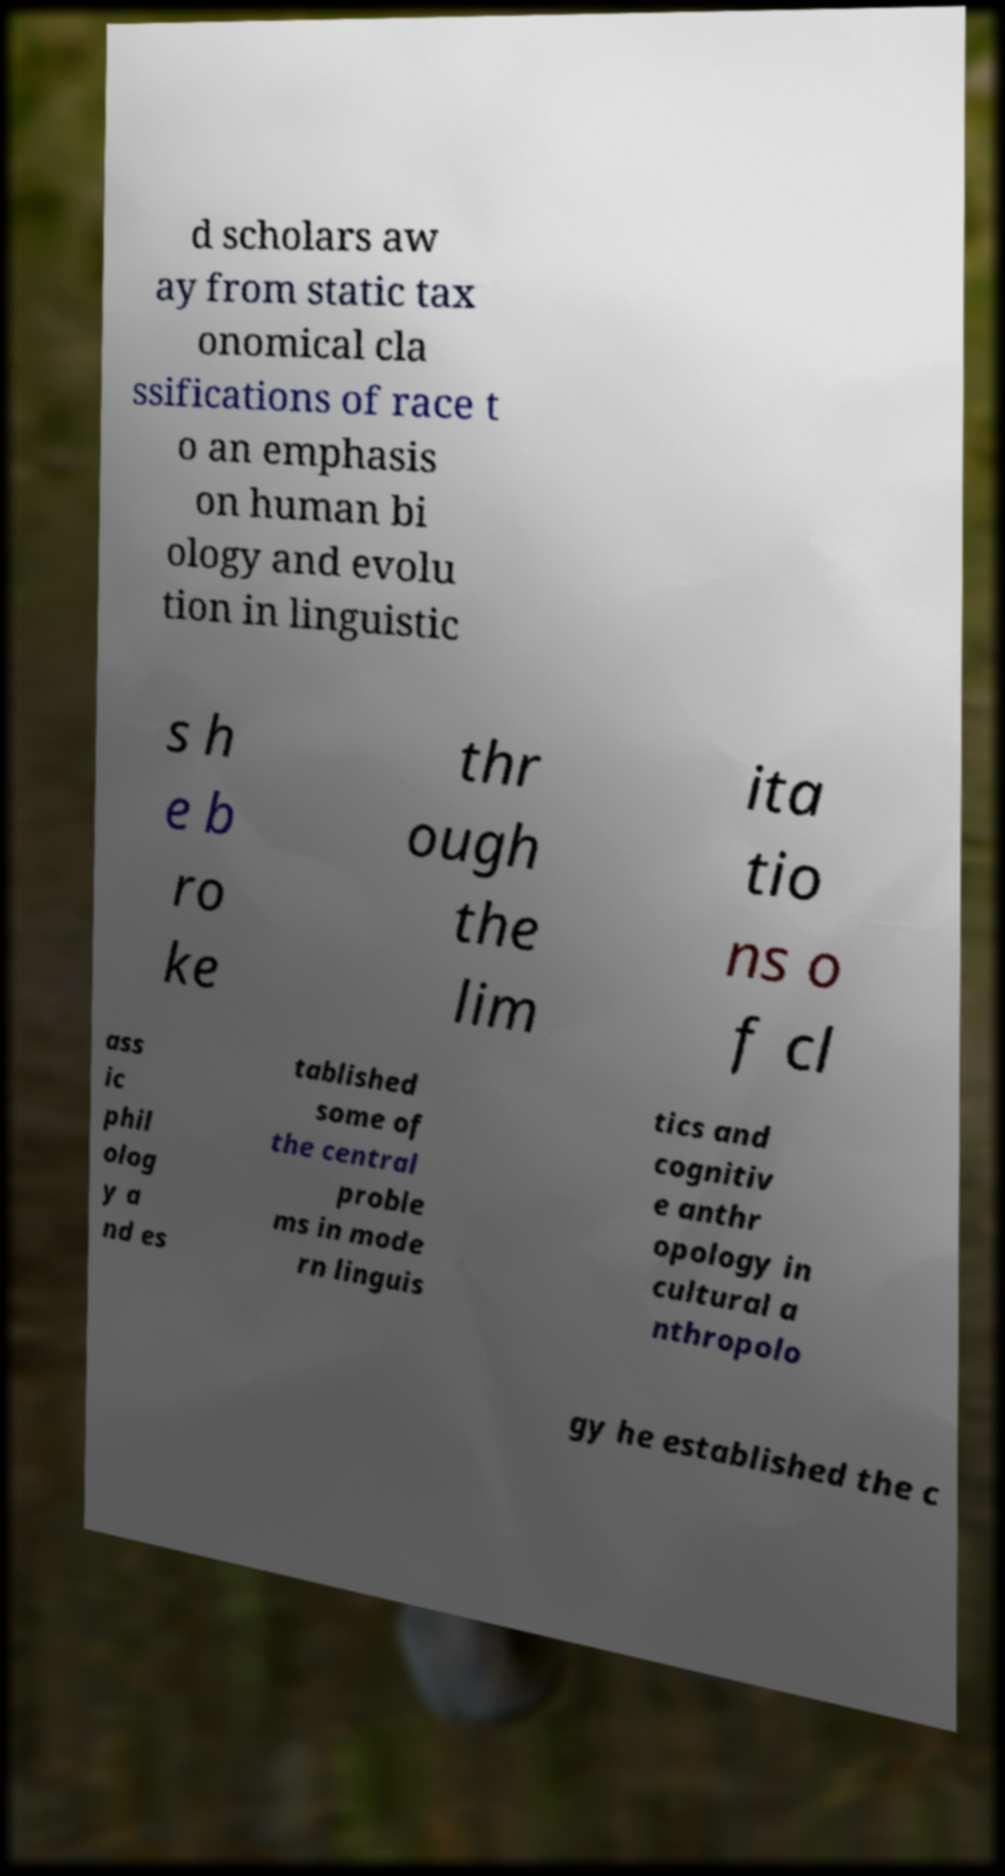What messages or text are displayed in this image? I need them in a readable, typed format. d scholars aw ay from static tax onomical cla ssifications of race t o an emphasis on human bi ology and evolu tion in linguistic s h e b ro ke thr ough the lim ita tio ns o f cl ass ic phil olog y a nd es tablished some of the central proble ms in mode rn linguis tics and cognitiv e anthr opology in cultural a nthropolo gy he established the c 